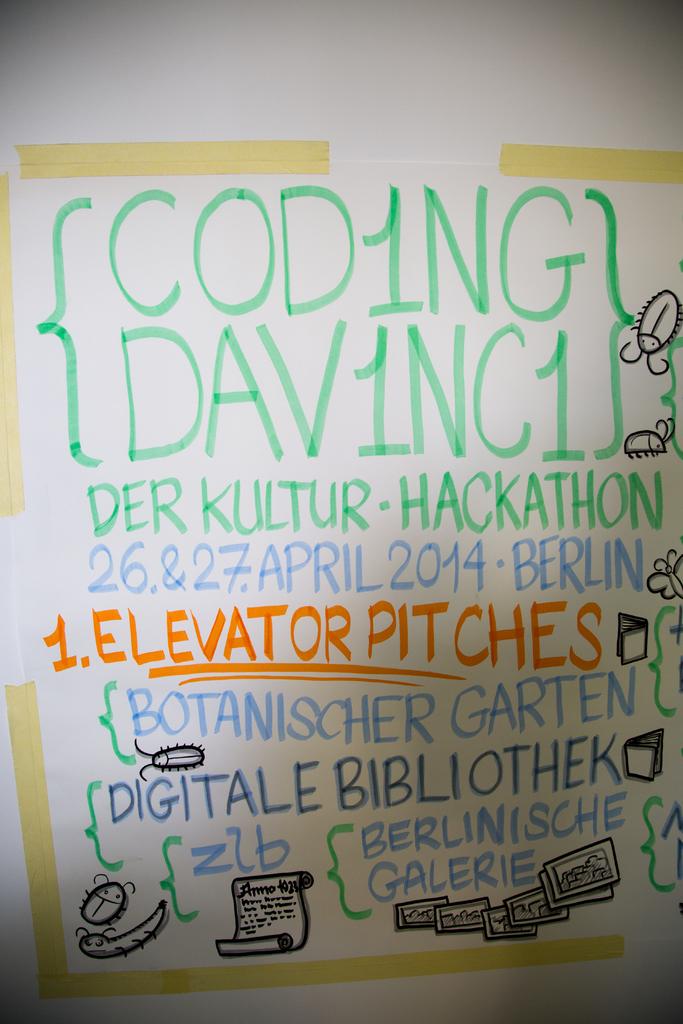What is written in orange text?
Offer a very short reply. 1. elevator pitches. 